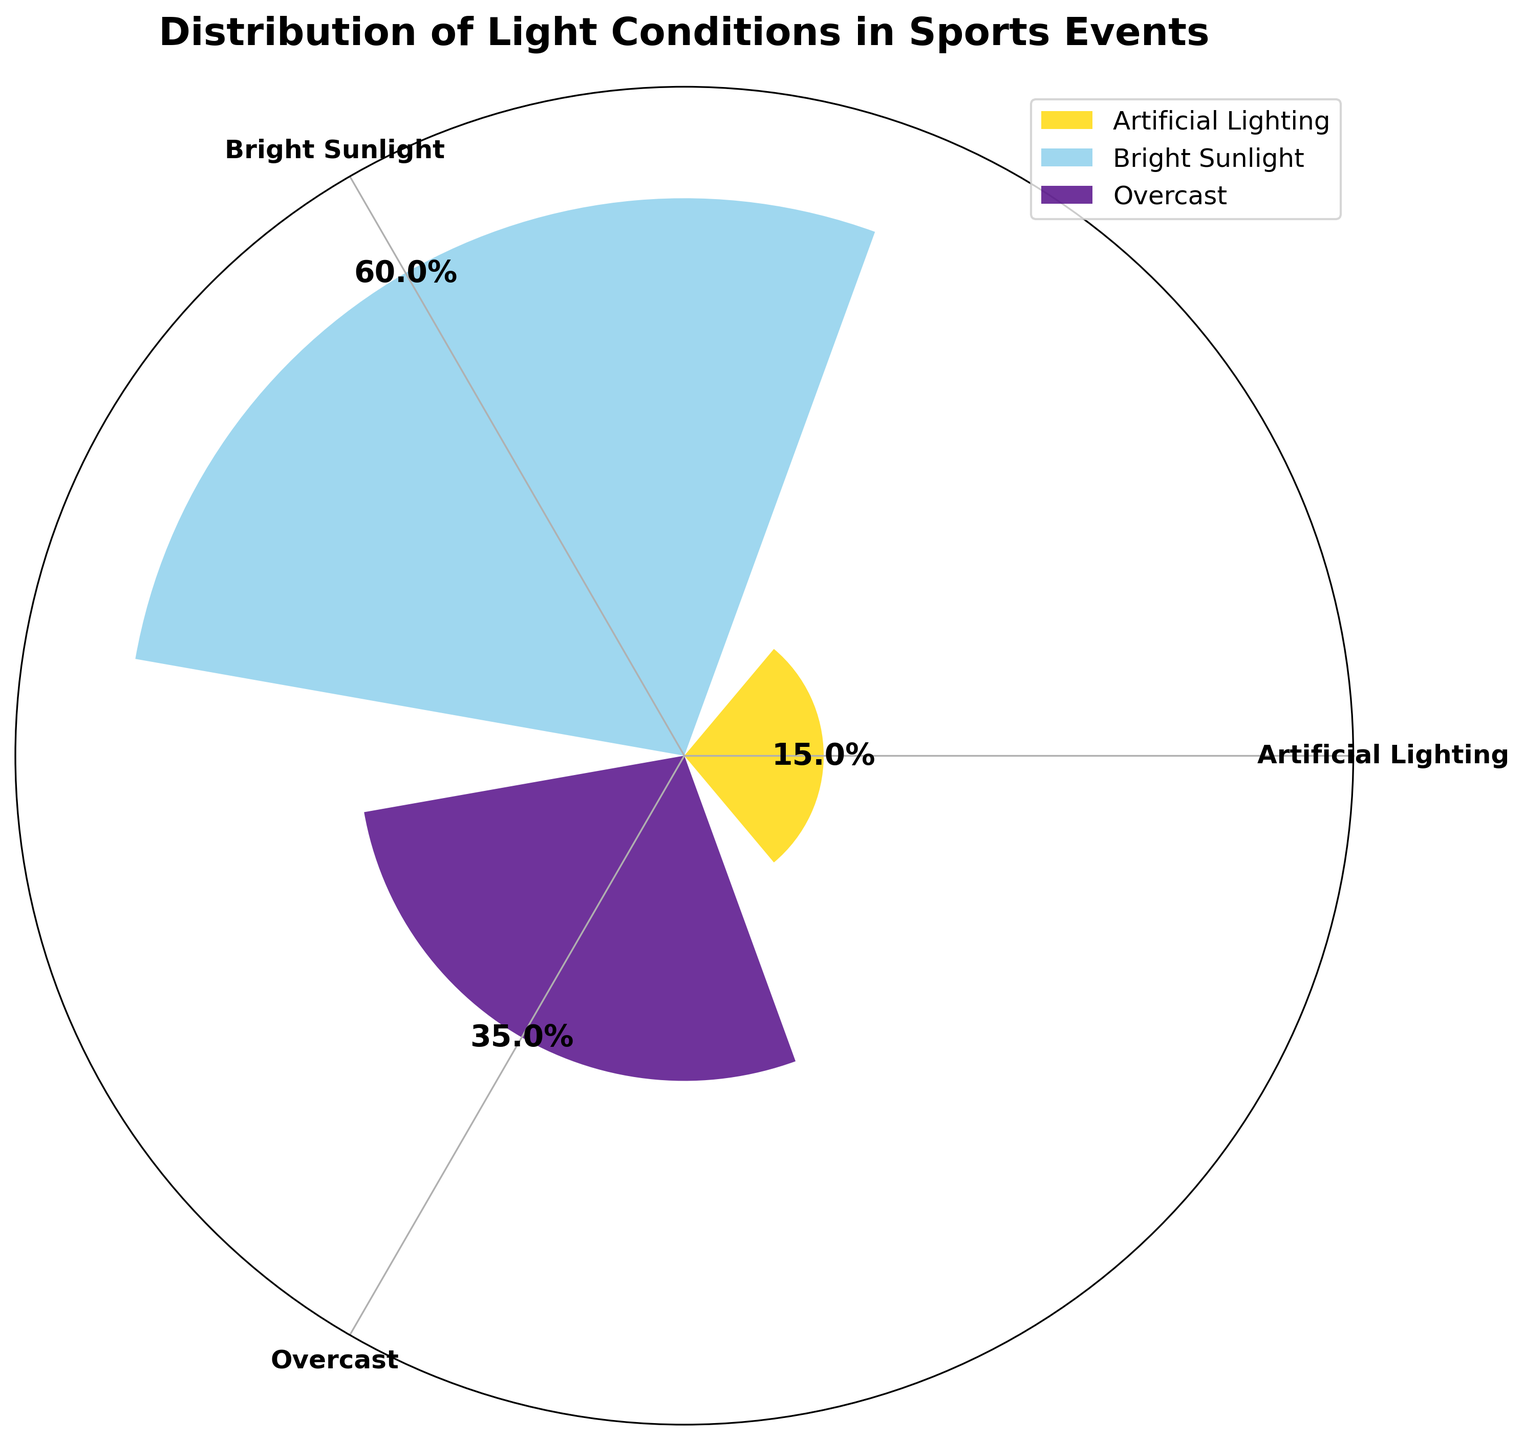What is the title of the figure? The title is typically located at the top of the figure. Here, the title is "Distribution of Light Conditions in Sports Events".
Answer: Distribution of Light Conditions in Sports Events Which light condition is present for the highest percentage of time? By observing the lengths of the radial bars, the longest bar corresponds to Bright Sunlight, indicating it has the highest percentage.
Answer: Bright Sunlight What light condition is represented by the shortest bar? The shortest bar in the rose chart represents the light condition with the lowest percentage. Here, it corresponds to Artificial Lighting.
Answer: Artificial Lighting How many light conditions are represented in the figure? By counting the distinct radial bars and their labels, we can see that there are three light conditions represented.
Answer: Three Compare the percentage time of Overcast and Artificial Lighting. Which one is greater? By observing the lengths of the respective bars, Overcast has a longer bar compared to Artificial Lighting, indicating a greater percentage.
Answer: Overcast What is the percentage sum of Overcast conditions throughout the event? Summing the Overcast percentages from the figure gives 10% + 15% + 10%.
Answer: 35% How much more percentage of time is there Bright Sunlight compared to Artificial Lighting? The total percentage of Bright Sunlight is 20% + 25% + 15% = 60%. The total percentage of Artificial Lighting is 5% + 10% = 15%. The difference is 60% - 15%.
Answer: 45% Which light condition is present for the second greatest amount of time? From the figure, the order of the length of the bars from longest to shortest is Bright Sunlight, Overcast, and Artificial Lighting, making Overcast the second greatest.
Answer: Overcast Among the three light conditions, which one covers exactly 20% of the time? By examining the bars, the one representing Bright Sunlight covers exactly 20% of the time, as indicated.
Answer: Bright Sunlight What visual elements are used to differentiate between different light conditions? The figure uses different colors to differentiate the light conditions: gold for Bright Sunlight, sky blue for Overcast, and indigo for Artificial Lighting.
Answer: Different colors 